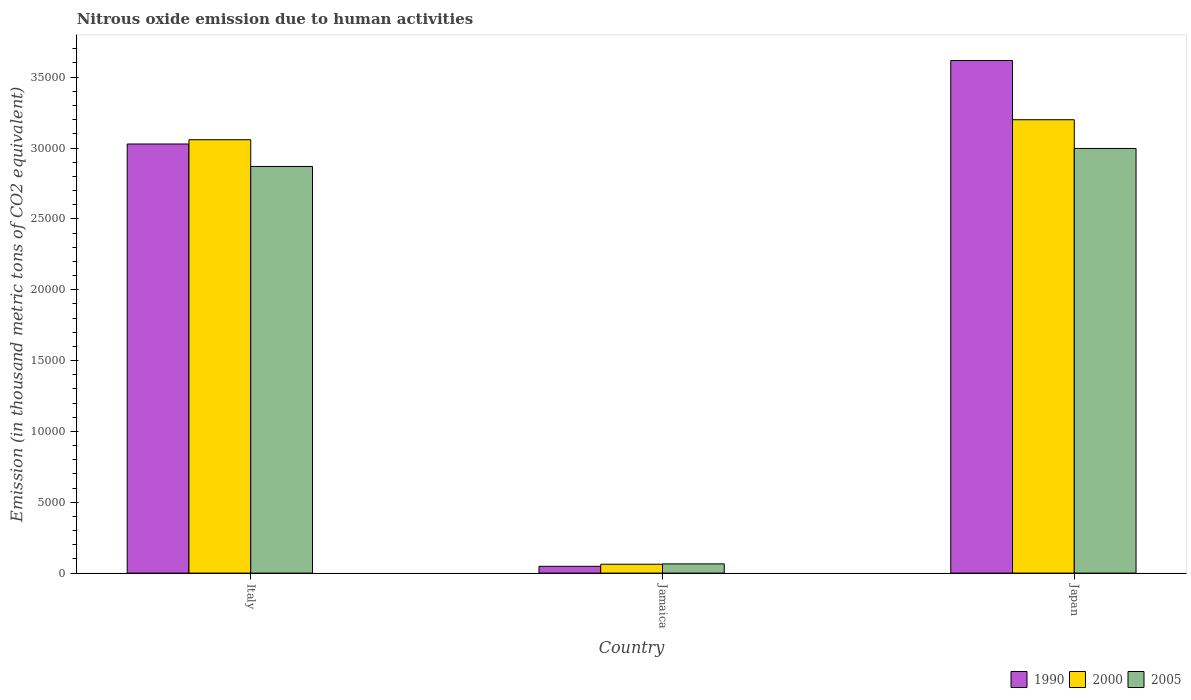How many different coloured bars are there?
Your answer should be very brief. 3. How many groups of bars are there?
Ensure brevity in your answer.  3. How many bars are there on the 2nd tick from the left?
Your answer should be very brief. 3. What is the label of the 2nd group of bars from the left?
Your response must be concise. Jamaica. What is the amount of nitrous oxide emitted in 2000 in Japan?
Provide a short and direct response. 3.20e+04. Across all countries, what is the maximum amount of nitrous oxide emitted in 2005?
Offer a terse response. 3.00e+04. Across all countries, what is the minimum amount of nitrous oxide emitted in 2000?
Offer a terse response. 626.2. In which country was the amount of nitrous oxide emitted in 1990 maximum?
Give a very brief answer. Japan. In which country was the amount of nitrous oxide emitted in 2000 minimum?
Your answer should be compact. Jamaica. What is the total amount of nitrous oxide emitted in 2000 in the graph?
Provide a succinct answer. 6.32e+04. What is the difference between the amount of nitrous oxide emitted in 2005 in Italy and that in Jamaica?
Your response must be concise. 2.80e+04. What is the difference between the amount of nitrous oxide emitted in 2005 in Italy and the amount of nitrous oxide emitted in 1990 in Japan?
Your answer should be compact. -7477.3. What is the average amount of nitrous oxide emitted in 2000 per country?
Offer a very short reply. 2.11e+04. What is the difference between the amount of nitrous oxide emitted of/in 2000 and amount of nitrous oxide emitted of/in 1990 in Japan?
Offer a terse response. -4179.1. In how many countries, is the amount of nitrous oxide emitted in 2000 greater than 35000 thousand metric tons?
Give a very brief answer. 0. What is the ratio of the amount of nitrous oxide emitted in 2005 in Italy to that in Jamaica?
Make the answer very short. 44.12. Is the amount of nitrous oxide emitted in 2005 in Italy less than that in Jamaica?
Your answer should be very brief. No. What is the difference between the highest and the second highest amount of nitrous oxide emitted in 1990?
Provide a short and direct response. -5892.4. What is the difference between the highest and the lowest amount of nitrous oxide emitted in 1990?
Offer a very short reply. 3.57e+04. Is the sum of the amount of nitrous oxide emitted in 1990 in Jamaica and Japan greater than the maximum amount of nitrous oxide emitted in 2005 across all countries?
Your answer should be very brief. Yes. What does the 2nd bar from the right in Jamaica represents?
Your response must be concise. 2000. Is it the case that in every country, the sum of the amount of nitrous oxide emitted in 2005 and amount of nitrous oxide emitted in 1990 is greater than the amount of nitrous oxide emitted in 2000?
Provide a succinct answer. Yes. Are all the bars in the graph horizontal?
Your response must be concise. No. Are the values on the major ticks of Y-axis written in scientific E-notation?
Provide a succinct answer. No. Does the graph contain any zero values?
Your answer should be compact. No. Does the graph contain grids?
Ensure brevity in your answer.  No. How many legend labels are there?
Make the answer very short. 3. How are the legend labels stacked?
Provide a short and direct response. Horizontal. What is the title of the graph?
Keep it short and to the point. Nitrous oxide emission due to human activities. What is the label or title of the X-axis?
Ensure brevity in your answer.  Country. What is the label or title of the Y-axis?
Your answer should be compact. Emission (in thousand metric tons of CO2 equivalent). What is the Emission (in thousand metric tons of CO2 equivalent) of 1990 in Italy?
Your answer should be very brief. 3.03e+04. What is the Emission (in thousand metric tons of CO2 equivalent) in 2000 in Italy?
Offer a terse response. 3.06e+04. What is the Emission (in thousand metric tons of CO2 equivalent) of 2005 in Italy?
Your response must be concise. 2.87e+04. What is the Emission (in thousand metric tons of CO2 equivalent) in 1990 in Jamaica?
Offer a terse response. 479.2. What is the Emission (in thousand metric tons of CO2 equivalent) in 2000 in Jamaica?
Provide a short and direct response. 626.2. What is the Emission (in thousand metric tons of CO2 equivalent) in 2005 in Jamaica?
Your answer should be compact. 650.5. What is the Emission (in thousand metric tons of CO2 equivalent) of 1990 in Japan?
Your answer should be very brief. 3.62e+04. What is the Emission (in thousand metric tons of CO2 equivalent) of 2000 in Japan?
Keep it short and to the point. 3.20e+04. What is the Emission (in thousand metric tons of CO2 equivalent) of 2005 in Japan?
Your answer should be very brief. 3.00e+04. Across all countries, what is the maximum Emission (in thousand metric tons of CO2 equivalent) in 1990?
Your response must be concise. 3.62e+04. Across all countries, what is the maximum Emission (in thousand metric tons of CO2 equivalent) in 2000?
Make the answer very short. 3.20e+04. Across all countries, what is the maximum Emission (in thousand metric tons of CO2 equivalent) of 2005?
Provide a succinct answer. 3.00e+04. Across all countries, what is the minimum Emission (in thousand metric tons of CO2 equivalent) of 1990?
Provide a succinct answer. 479.2. Across all countries, what is the minimum Emission (in thousand metric tons of CO2 equivalent) of 2000?
Provide a succinct answer. 626.2. Across all countries, what is the minimum Emission (in thousand metric tons of CO2 equivalent) of 2005?
Offer a very short reply. 650.5. What is the total Emission (in thousand metric tons of CO2 equivalent) in 1990 in the graph?
Your response must be concise. 6.69e+04. What is the total Emission (in thousand metric tons of CO2 equivalent) in 2000 in the graph?
Ensure brevity in your answer.  6.32e+04. What is the total Emission (in thousand metric tons of CO2 equivalent) of 2005 in the graph?
Give a very brief answer. 5.93e+04. What is the difference between the Emission (in thousand metric tons of CO2 equivalent) in 1990 in Italy and that in Jamaica?
Offer a very short reply. 2.98e+04. What is the difference between the Emission (in thousand metric tons of CO2 equivalent) of 2000 in Italy and that in Jamaica?
Your answer should be very brief. 3.00e+04. What is the difference between the Emission (in thousand metric tons of CO2 equivalent) of 2005 in Italy and that in Jamaica?
Provide a succinct answer. 2.80e+04. What is the difference between the Emission (in thousand metric tons of CO2 equivalent) in 1990 in Italy and that in Japan?
Give a very brief answer. -5892.4. What is the difference between the Emission (in thousand metric tons of CO2 equivalent) in 2000 in Italy and that in Japan?
Make the answer very short. -1412.1. What is the difference between the Emission (in thousand metric tons of CO2 equivalent) of 2005 in Italy and that in Japan?
Your response must be concise. -1270.7. What is the difference between the Emission (in thousand metric tons of CO2 equivalent) of 1990 in Jamaica and that in Japan?
Give a very brief answer. -3.57e+04. What is the difference between the Emission (in thousand metric tons of CO2 equivalent) in 2000 in Jamaica and that in Japan?
Ensure brevity in your answer.  -3.14e+04. What is the difference between the Emission (in thousand metric tons of CO2 equivalent) in 2005 in Jamaica and that in Japan?
Provide a succinct answer. -2.93e+04. What is the difference between the Emission (in thousand metric tons of CO2 equivalent) of 1990 in Italy and the Emission (in thousand metric tons of CO2 equivalent) of 2000 in Jamaica?
Offer a terse response. 2.97e+04. What is the difference between the Emission (in thousand metric tons of CO2 equivalent) of 1990 in Italy and the Emission (in thousand metric tons of CO2 equivalent) of 2005 in Jamaica?
Provide a short and direct response. 2.96e+04. What is the difference between the Emission (in thousand metric tons of CO2 equivalent) of 2000 in Italy and the Emission (in thousand metric tons of CO2 equivalent) of 2005 in Jamaica?
Your response must be concise. 2.99e+04. What is the difference between the Emission (in thousand metric tons of CO2 equivalent) in 1990 in Italy and the Emission (in thousand metric tons of CO2 equivalent) in 2000 in Japan?
Your response must be concise. -1713.3. What is the difference between the Emission (in thousand metric tons of CO2 equivalent) in 1990 in Italy and the Emission (in thousand metric tons of CO2 equivalent) in 2005 in Japan?
Provide a succinct answer. 314.2. What is the difference between the Emission (in thousand metric tons of CO2 equivalent) in 2000 in Italy and the Emission (in thousand metric tons of CO2 equivalent) in 2005 in Japan?
Keep it short and to the point. 615.4. What is the difference between the Emission (in thousand metric tons of CO2 equivalent) in 1990 in Jamaica and the Emission (in thousand metric tons of CO2 equivalent) in 2000 in Japan?
Provide a short and direct response. -3.15e+04. What is the difference between the Emission (in thousand metric tons of CO2 equivalent) of 1990 in Jamaica and the Emission (in thousand metric tons of CO2 equivalent) of 2005 in Japan?
Make the answer very short. -2.95e+04. What is the difference between the Emission (in thousand metric tons of CO2 equivalent) of 2000 in Jamaica and the Emission (in thousand metric tons of CO2 equivalent) of 2005 in Japan?
Keep it short and to the point. -2.93e+04. What is the average Emission (in thousand metric tons of CO2 equivalent) in 1990 per country?
Your response must be concise. 2.23e+04. What is the average Emission (in thousand metric tons of CO2 equivalent) of 2000 per country?
Offer a terse response. 2.11e+04. What is the average Emission (in thousand metric tons of CO2 equivalent) in 2005 per country?
Make the answer very short. 1.98e+04. What is the difference between the Emission (in thousand metric tons of CO2 equivalent) in 1990 and Emission (in thousand metric tons of CO2 equivalent) in 2000 in Italy?
Give a very brief answer. -301.2. What is the difference between the Emission (in thousand metric tons of CO2 equivalent) in 1990 and Emission (in thousand metric tons of CO2 equivalent) in 2005 in Italy?
Offer a very short reply. 1584.9. What is the difference between the Emission (in thousand metric tons of CO2 equivalent) in 2000 and Emission (in thousand metric tons of CO2 equivalent) in 2005 in Italy?
Keep it short and to the point. 1886.1. What is the difference between the Emission (in thousand metric tons of CO2 equivalent) of 1990 and Emission (in thousand metric tons of CO2 equivalent) of 2000 in Jamaica?
Provide a short and direct response. -147. What is the difference between the Emission (in thousand metric tons of CO2 equivalent) of 1990 and Emission (in thousand metric tons of CO2 equivalent) of 2005 in Jamaica?
Provide a short and direct response. -171.3. What is the difference between the Emission (in thousand metric tons of CO2 equivalent) in 2000 and Emission (in thousand metric tons of CO2 equivalent) in 2005 in Jamaica?
Your response must be concise. -24.3. What is the difference between the Emission (in thousand metric tons of CO2 equivalent) of 1990 and Emission (in thousand metric tons of CO2 equivalent) of 2000 in Japan?
Ensure brevity in your answer.  4179.1. What is the difference between the Emission (in thousand metric tons of CO2 equivalent) in 1990 and Emission (in thousand metric tons of CO2 equivalent) in 2005 in Japan?
Provide a short and direct response. 6206.6. What is the difference between the Emission (in thousand metric tons of CO2 equivalent) in 2000 and Emission (in thousand metric tons of CO2 equivalent) in 2005 in Japan?
Give a very brief answer. 2027.5. What is the ratio of the Emission (in thousand metric tons of CO2 equivalent) of 1990 in Italy to that in Jamaica?
Offer a terse response. 63.19. What is the ratio of the Emission (in thousand metric tons of CO2 equivalent) in 2000 in Italy to that in Jamaica?
Your answer should be compact. 48.84. What is the ratio of the Emission (in thousand metric tons of CO2 equivalent) of 2005 in Italy to that in Jamaica?
Your response must be concise. 44.12. What is the ratio of the Emission (in thousand metric tons of CO2 equivalent) of 1990 in Italy to that in Japan?
Make the answer very short. 0.84. What is the ratio of the Emission (in thousand metric tons of CO2 equivalent) of 2000 in Italy to that in Japan?
Provide a short and direct response. 0.96. What is the ratio of the Emission (in thousand metric tons of CO2 equivalent) in 2005 in Italy to that in Japan?
Your answer should be very brief. 0.96. What is the ratio of the Emission (in thousand metric tons of CO2 equivalent) in 1990 in Jamaica to that in Japan?
Your answer should be compact. 0.01. What is the ratio of the Emission (in thousand metric tons of CO2 equivalent) in 2000 in Jamaica to that in Japan?
Your response must be concise. 0.02. What is the ratio of the Emission (in thousand metric tons of CO2 equivalent) in 2005 in Jamaica to that in Japan?
Your response must be concise. 0.02. What is the difference between the highest and the second highest Emission (in thousand metric tons of CO2 equivalent) of 1990?
Provide a succinct answer. 5892.4. What is the difference between the highest and the second highest Emission (in thousand metric tons of CO2 equivalent) in 2000?
Offer a terse response. 1412.1. What is the difference between the highest and the second highest Emission (in thousand metric tons of CO2 equivalent) of 2005?
Offer a terse response. 1270.7. What is the difference between the highest and the lowest Emission (in thousand metric tons of CO2 equivalent) in 1990?
Your response must be concise. 3.57e+04. What is the difference between the highest and the lowest Emission (in thousand metric tons of CO2 equivalent) in 2000?
Provide a short and direct response. 3.14e+04. What is the difference between the highest and the lowest Emission (in thousand metric tons of CO2 equivalent) in 2005?
Ensure brevity in your answer.  2.93e+04. 